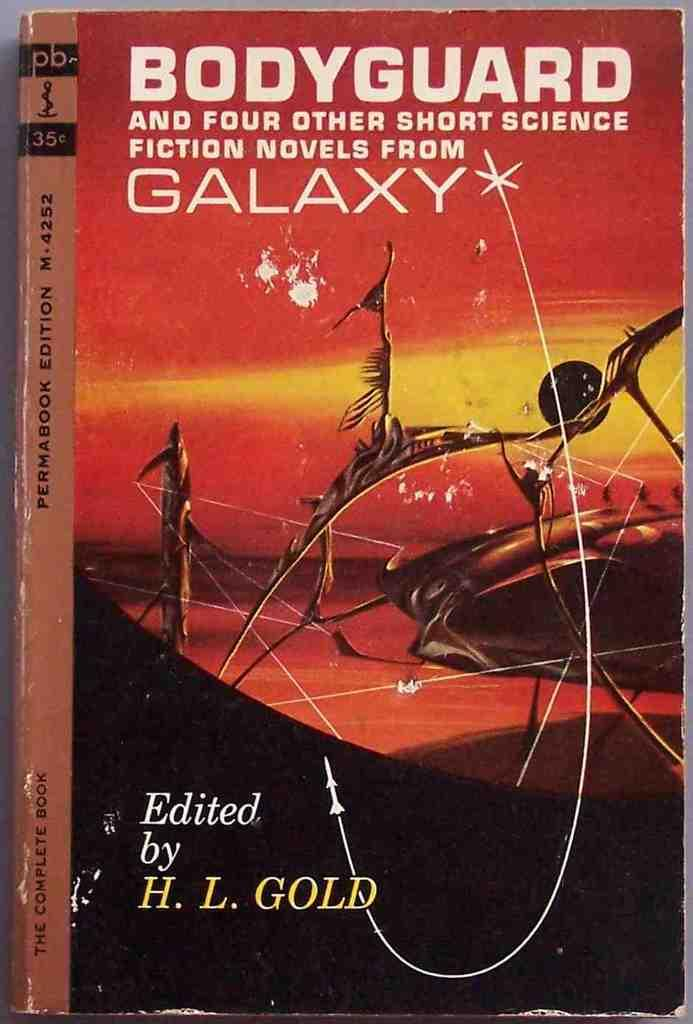<image>
Render a clear and concise summary of the photo. Book of the Bodyguard and four other short science fiction novels from the galaxy, which is edited by H.L. Gold. 